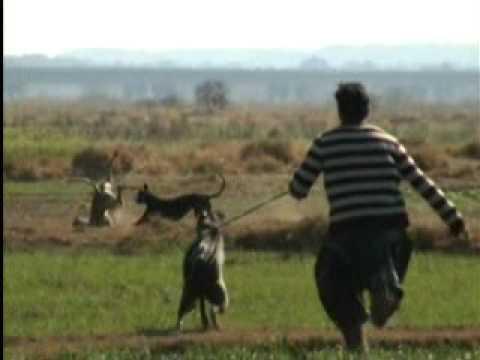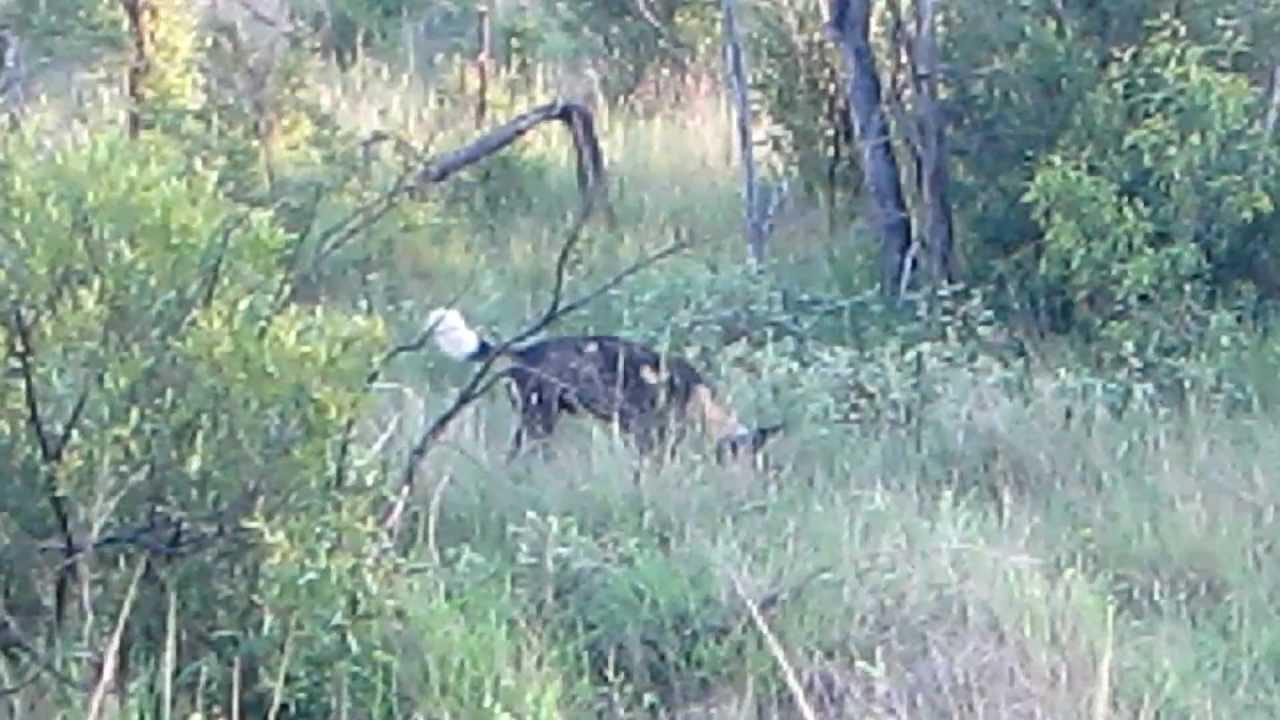The first image is the image on the left, the second image is the image on the right. Analyze the images presented: Is the assertion "One animal is on a leash." valid? Answer yes or no. Yes. The first image is the image on the left, the second image is the image on the right. Assess this claim about the two images: "An image shows one hound running in front of another and kicking up clouds of dust.". Correct or not? Answer yes or no. No. 